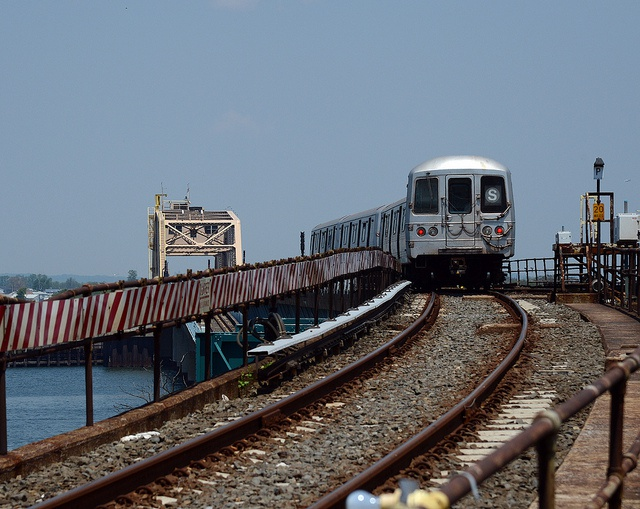Describe the objects in this image and their specific colors. I can see a train in darkgray, black, and gray tones in this image. 